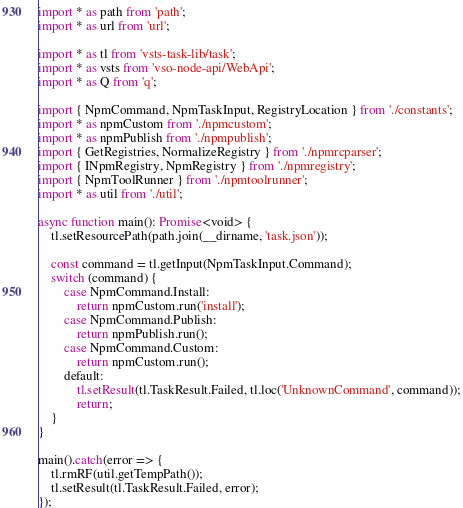<code> <loc_0><loc_0><loc_500><loc_500><_TypeScript_>import * as path from 'path';
import * as url from 'url';

import * as tl from 'vsts-task-lib/task';
import * as vsts from 'vso-node-api/WebApi';
import * as Q from 'q';

import { NpmCommand, NpmTaskInput, RegistryLocation } from './constants';
import * as npmCustom from './npmcustom';
import * as npmPublish from './npmpublish';
import { GetRegistries, NormalizeRegistry } from './npmrcparser';
import { INpmRegistry, NpmRegistry } from './npmregistry';
import { NpmToolRunner } from './npmtoolrunner';
import * as util from './util';

async function main(): Promise<void> {
    tl.setResourcePath(path.join(__dirname, 'task.json'));

    const command = tl.getInput(NpmTaskInput.Command);
    switch (command) {
        case NpmCommand.Install:
            return npmCustom.run('install');
        case NpmCommand.Publish:
            return npmPublish.run();
        case NpmCommand.Custom:
            return npmCustom.run();
        default:
            tl.setResult(tl.TaskResult.Failed, tl.loc('UnknownCommand', command));
            return;
    }
}

main().catch(error => {
    tl.rmRF(util.getTempPath());
    tl.setResult(tl.TaskResult.Failed, error);
});
</code> 